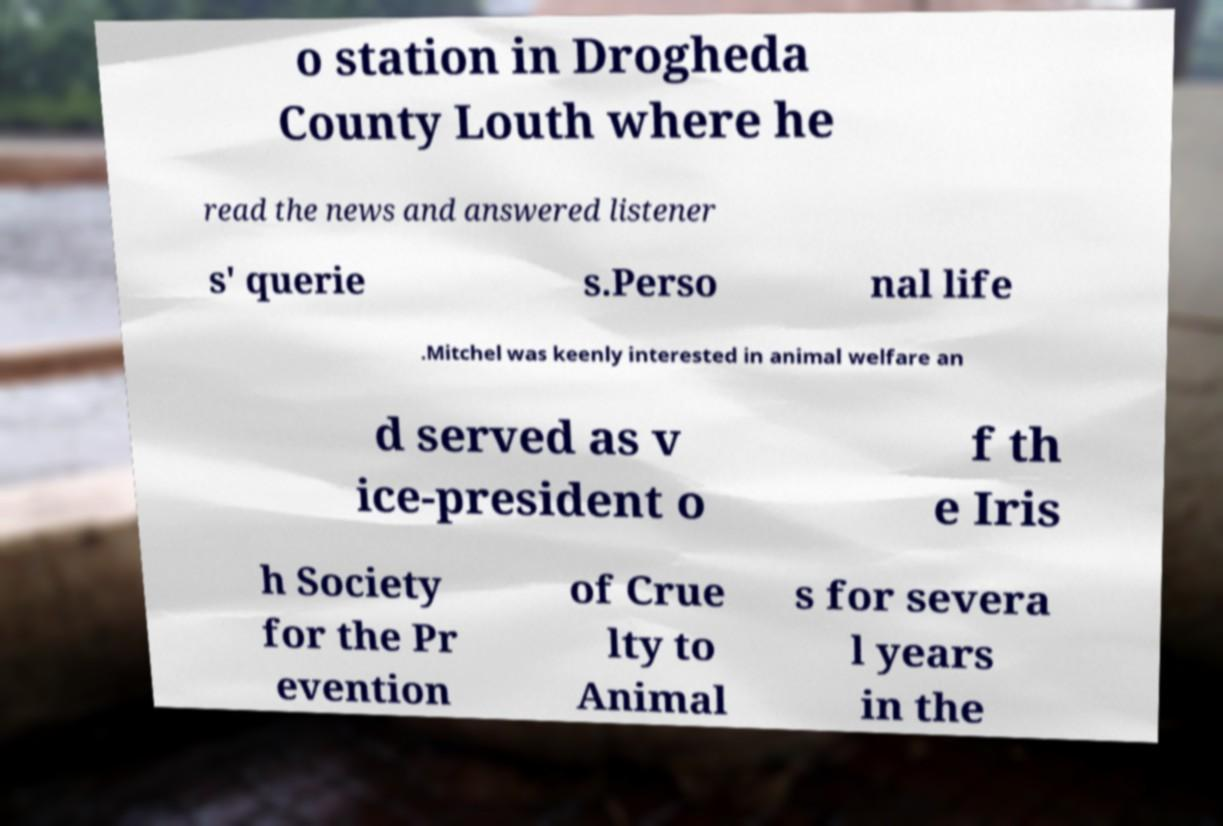I need the written content from this picture converted into text. Can you do that? o station in Drogheda County Louth where he read the news and answered listener s' querie s.Perso nal life .Mitchel was keenly interested in animal welfare an d served as v ice-president o f th e Iris h Society for the Pr evention of Crue lty to Animal s for severa l years in the 